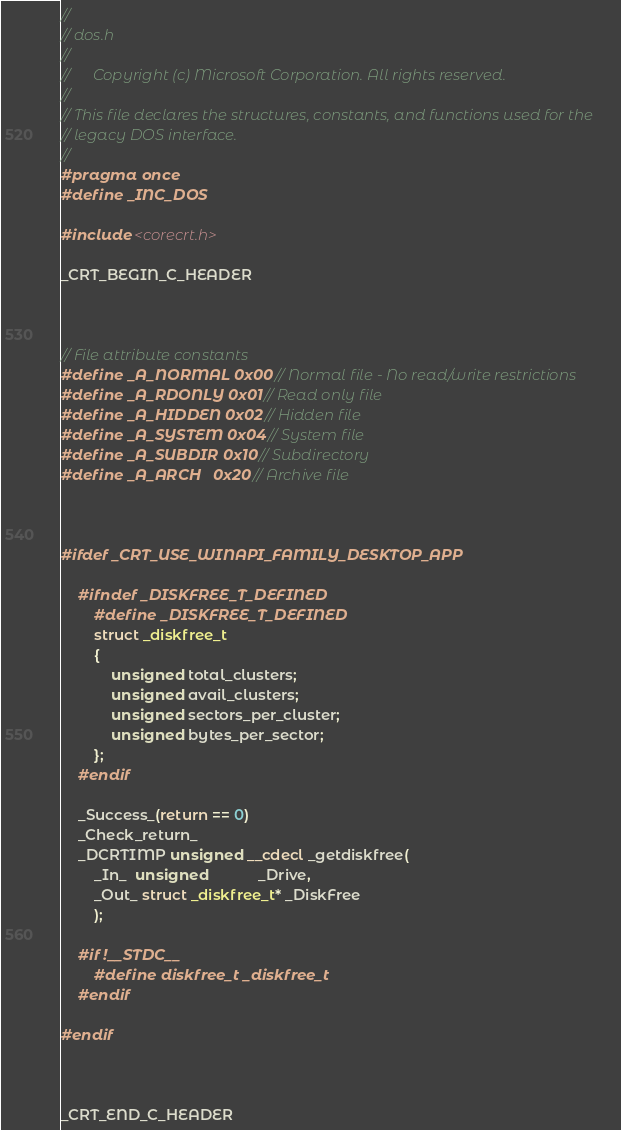Convert code to text. <code><loc_0><loc_0><loc_500><loc_500><_C_>//
// dos.h
//
//      Copyright (c) Microsoft Corporation. All rights reserved.
//
// This file declares the structures, constants, and functions used for the
// legacy DOS interface.
//
#pragma once
#define _INC_DOS

#include <corecrt.h>

_CRT_BEGIN_C_HEADER



// File attribute constants
#define _A_NORMAL 0x00 // Normal file - No read/write restrictions
#define _A_RDONLY 0x01 // Read only file
#define _A_HIDDEN 0x02 // Hidden file
#define _A_SYSTEM 0x04 // System file
#define _A_SUBDIR 0x10 // Subdirectory
#define _A_ARCH   0x20 // Archive file



#ifdef _CRT_USE_WINAPI_FAMILY_DESKTOP_APP

    #ifndef _DISKFREE_T_DEFINED
        #define _DISKFREE_T_DEFINED
        struct _diskfree_t
        {
            unsigned total_clusters;
            unsigned avail_clusters;
            unsigned sectors_per_cluster;
            unsigned bytes_per_sector;
        };
    #endif

    _Success_(return == 0)
    _Check_return_
    _DCRTIMP unsigned __cdecl _getdiskfree(
        _In_  unsigned            _Drive,
        _Out_ struct _diskfree_t* _DiskFree
        );

    #if !__STDC__
        #define diskfree_t _diskfree_t
    #endif

#endif



_CRT_END_C_HEADER
</code> 